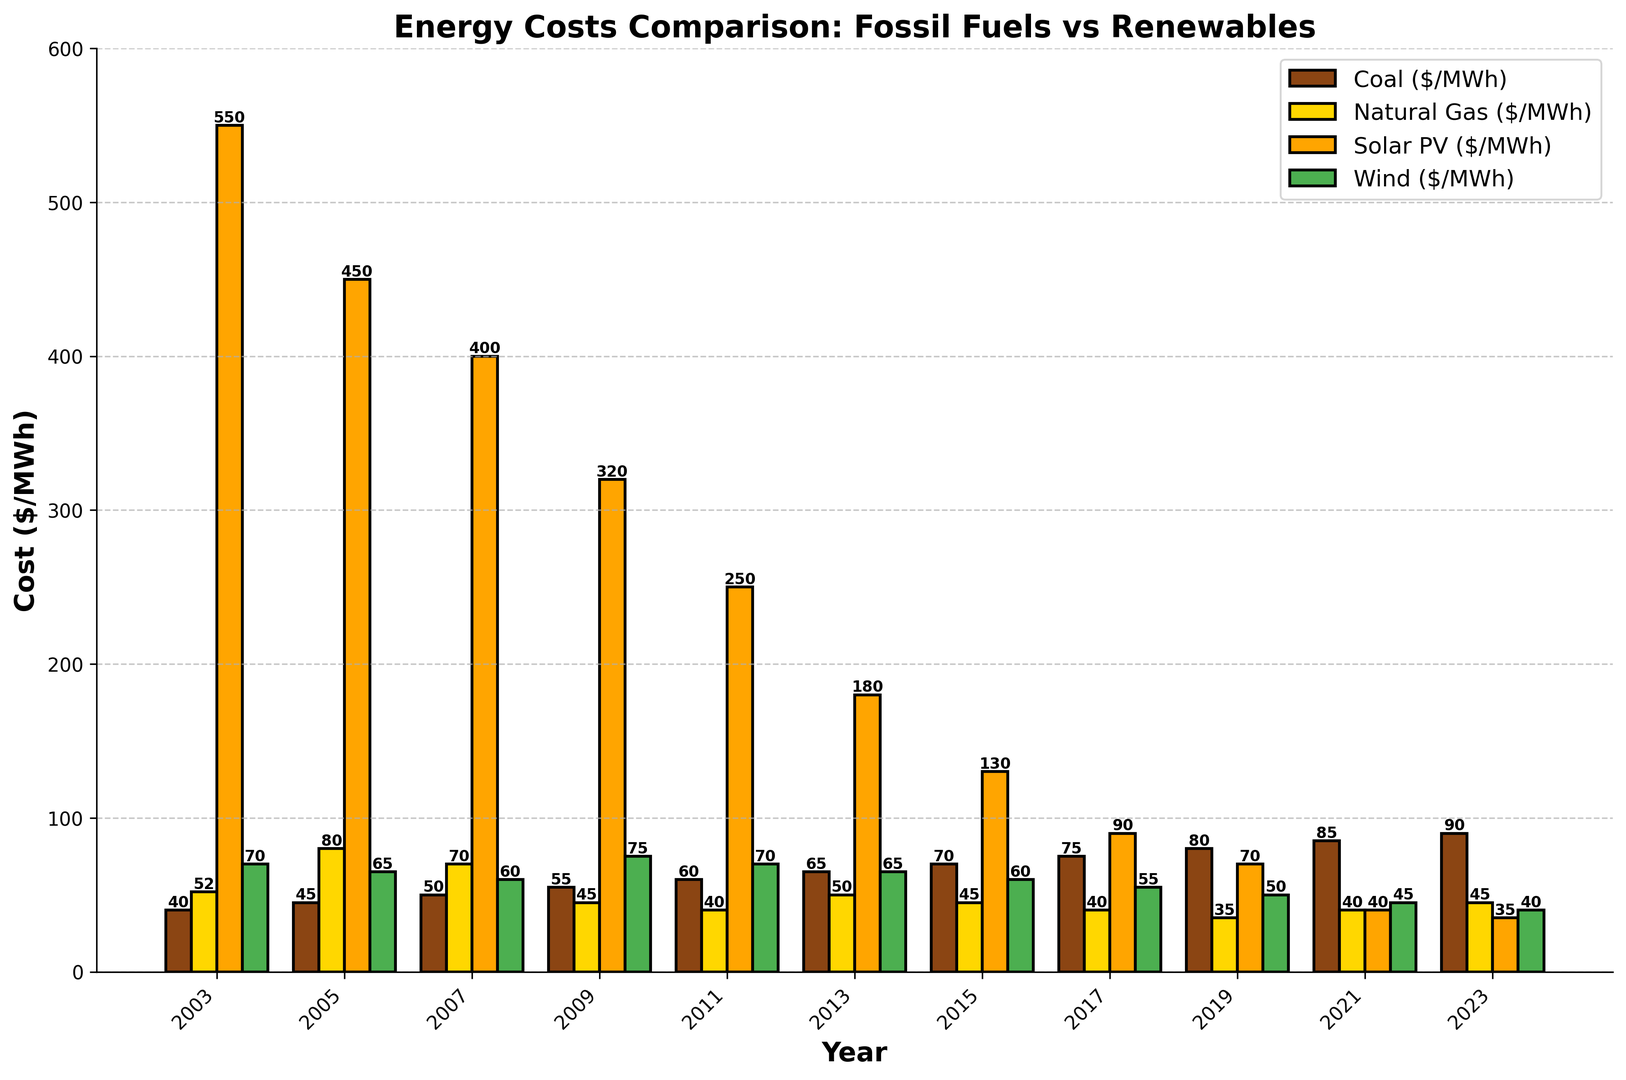Which year saw the highest cost for coal energy? By looking at the height of the brown bars across all years, the tallest one signifies the year with the highest cost. The tallest brown bar is in 2023.
Answer: 2023 What is the difference in cost between Solar PV and Wind energy in 2003? To find the difference, identify the heights of the orange bar (Solar PV: 550 $/MWh) and green bar (Wind: 70 $/MWh) in 2003 and subtract the Wind cost from the Solar PV cost. So, 550 - 70 = 480.
Answer: 480 Which energy source showed a generally decreasing trend over the 20 years? Observing the heights of bars over the timeline for each energy source, the orange bars (Solar PV) consistently decrease from 550 $/MWh in 2003 to 35 $/MWh in 2023.
Answer: Solar PV In which year did Natural Gas have the lowest cost? By examining the heights of the yellow bars, the shortest one indicates the year with the lowest cost. The shortest yellow bar is in 2019.
Answer: 2019 How does the cost of Wind energy in 2023 compare to its cost in 2003? The green bar in 2023 is shorter than in 2003. By identifying the exact heights, Wind cost was 70 $/MWh in 2003 and 40 $/MWh in 2023. Therefore, the cost decreased.
Answer: Decreased What is the combined cost of Solar PV and Wind energy in 2021? Locate the heights of the orange and green bars in 2021. Solar PV is 40 $/MWh and Wind is 45 $/MWh. Adding them together gives 40 + 45 = 85.
Answer: 85 Which fossil fuel had the higher cost in 2015? Compare the heights of the brown bar (Coal: 70 $/MWh) and the yellow bar (Natural Gas: 45 $/MWh) in 2015. The brown bar is taller, indicating Coal had the higher cost.
Answer: Coal What's the average cost of Natural Gas across all years shown? To find the average, sum all Natural Gas costs (52 + 80 + 70 + 45 + 40 + 50 + 45 + 40 + 35 + 40 + 45 = 542) and divide by the number of years (11). So, 542 / 11 = 49.27.
Answer: 49.27 By how much did the cost of Coal increase from 2003 to 2023? Identify the heights of the brown bars in 2003 (40 $/MWh) and 2023 (90 $/MWh). Subtract the 2003 cost from the 2023 cost, so 90 - 40 = 50.
Answer: 50 What's the trend in the cost of Wind energy from 2011 to 2023? Observing the green bars from 2011 to 2023, they consistently decrease from 70 $/MWh in 2011 to 40 $/MWh in 2023. Thus, the trend is decreasing.
Answer: Decreasing 